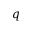<formula> <loc_0><loc_0><loc_500><loc_500>q</formula> 